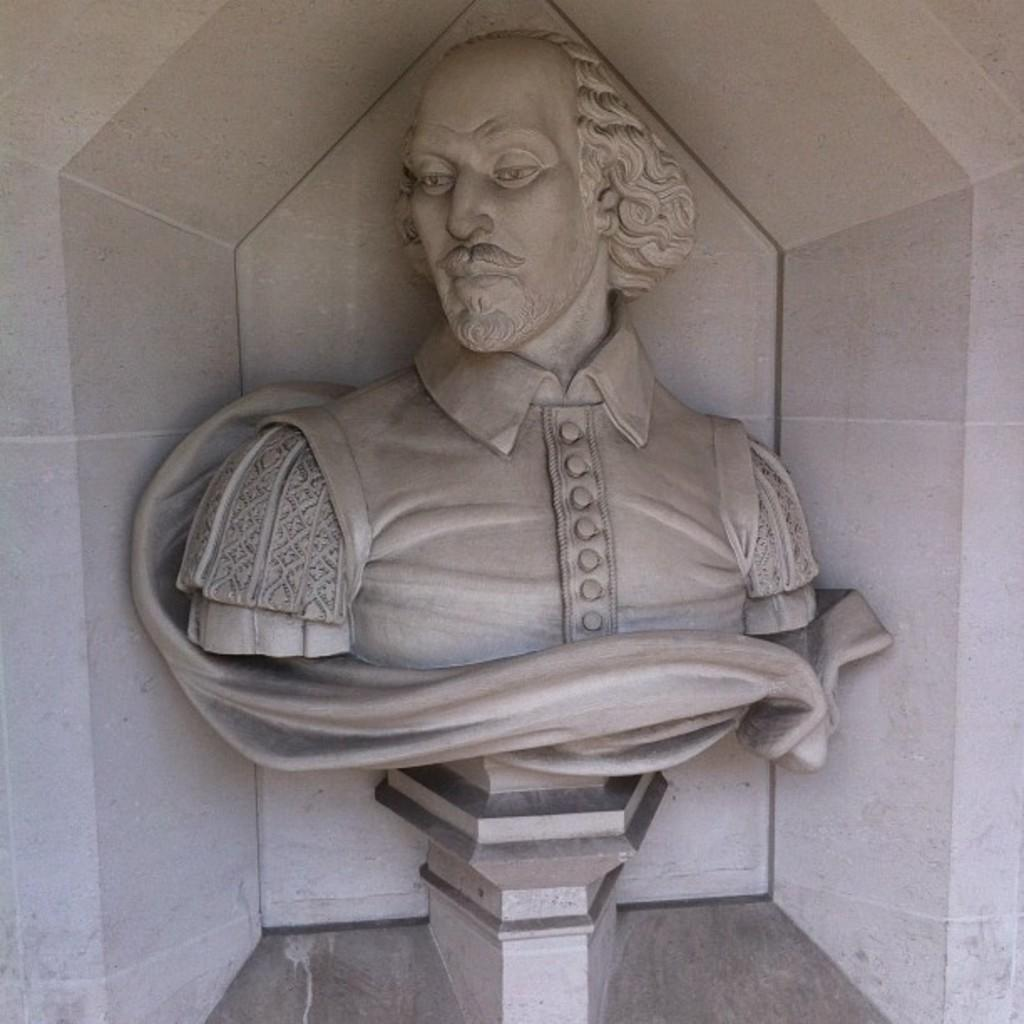What is the main structure visible in the image? There is a white construction in the image. What is the object placed on the white construction? There is an idol of a person in the image. What is the color of the idol? The idol is white in color. How is the idol positioned in the image? The idol is placed on a stone stand. What is the desire of the person standing on the hill in the image? There is no person standing on a hill in the image; the idol is placed on a stone stand. 